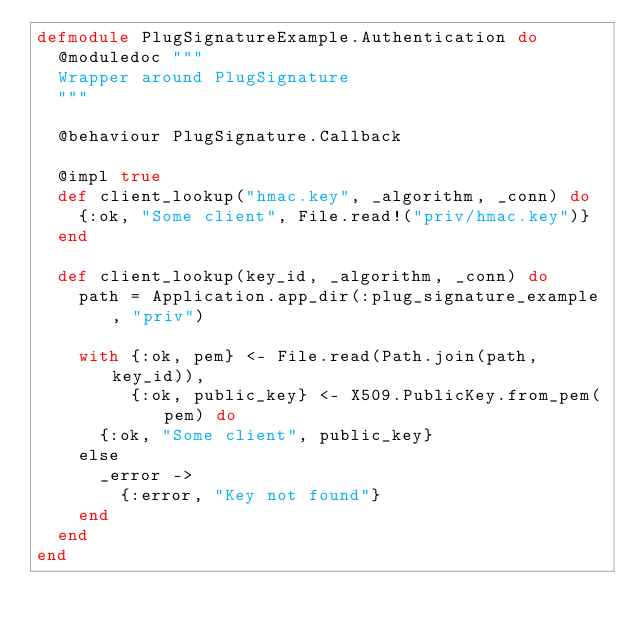Convert code to text. <code><loc_0><loc_0><loc_500><loc_500><_Elixir_>defmodule PlugSignatureExample.Authentication do
  @moduledoc """
  Wrapper around PlugSignature
  """

  @behaviour PlugSignature.Callback

  @impl true
  def client_lookup("hmac.key", _algorithm, _conn) do
    {:ok, "Some client", File.read!("priv/hmac.key")}
  end

  def client_lookup(key_id, _algorithm, _conn) do
    path = Application.app_dir(:plug_signature_example, "priv")

    with {:ok, pem} <- File.read(Path.join(path, key_id)),
         {:ok, public_key} <- X509.PublicKey.from_pem(pem) do
      {:ok, "Some client", public_key}
    else
      _error ->
        {:error, "Key not found"}
    end
  end
end
</code> 